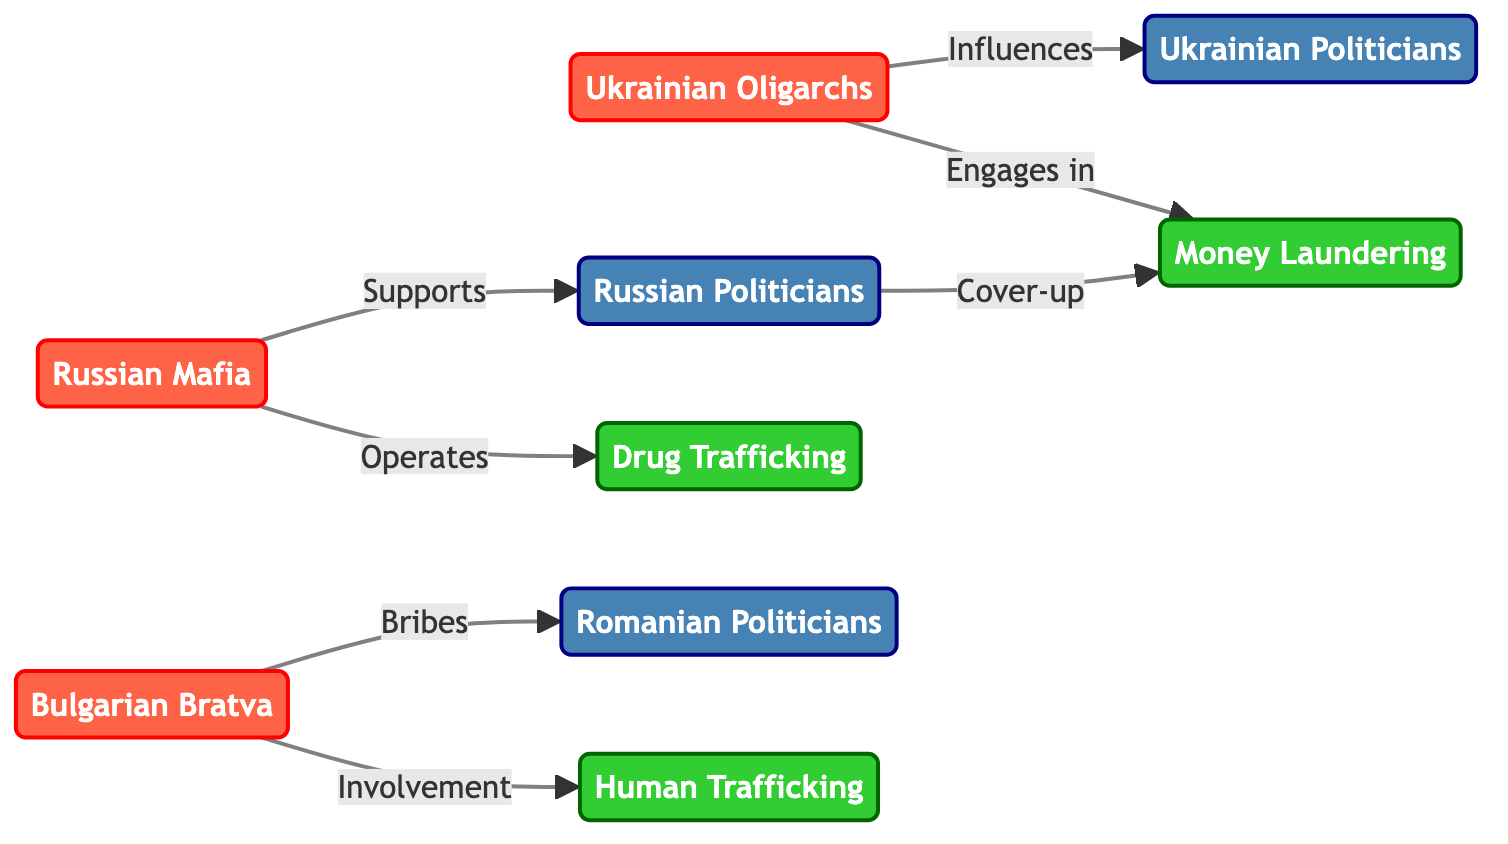What is the total number of nodes in the diagram? The diagram lists the nodes under the "nodes" section, which contains a total of nine entries: three crime organizations, three political entities, and three criminal activities.
Answer: 9 What relationship exists between the Russian Mafia and Russian Politicians? In the diagram, the Russian Mafia has a directed edge labeled "Supports" that connects it to Russian Politicians, indicating a support relationship.
Answer: Supports How many edges are there connecting crime organizations to criminal activities? By reviewing the edges section, we can find that there are three edges that connect the three crime organizations to their respective criminal activities.
Answer: 3 Which organization engages in money laundering? The Ukrainian Oligarchs have a directed edge labeled "Engages in" that connects them to Money Laundering, indicating their involvement in that activity.
Answer: Ukrainian Oligarchs What type of relationship is depicted between the Bulgarian Bratva and Romanian Politicians? An edge marked "Bribes" connects the Bulgarian Bratva to Romanian Politicians, demonstrating that the crime organization provides bribes to the political entity.
Answer: Bribes Which crime activity does the Russian Mafia operate in? The diagram shows that the Russian Mafia has a directed edge to Drug Trafficking with the label "Operates," indicating their involvement in this activity.
Answer: Drug Trafficking What connection does the Russian Politicians have with Money Laundering? According to the diagram, there is an edge leading from Russian Politicians to Money Laundering labeled "Cover-up," depicting their involvement in concealing illegitimate financial activities.
Answer: Cover-up Who influences Ukrainian Politicians? The Ukrainian Oligarchs have a directed edge labeled "Influences" that leads to Ukrainian Politicians, indicating their power to influence this political entity.
Answer: Ukrainian Oligarchs Which entity is involved in Human Trafficking? The Bulgarian Bratva has a directed edge indicating "Involvement" in Human Trafficking, showing their participation in this criminal activity.
Answer: Bulgarian Bratva 